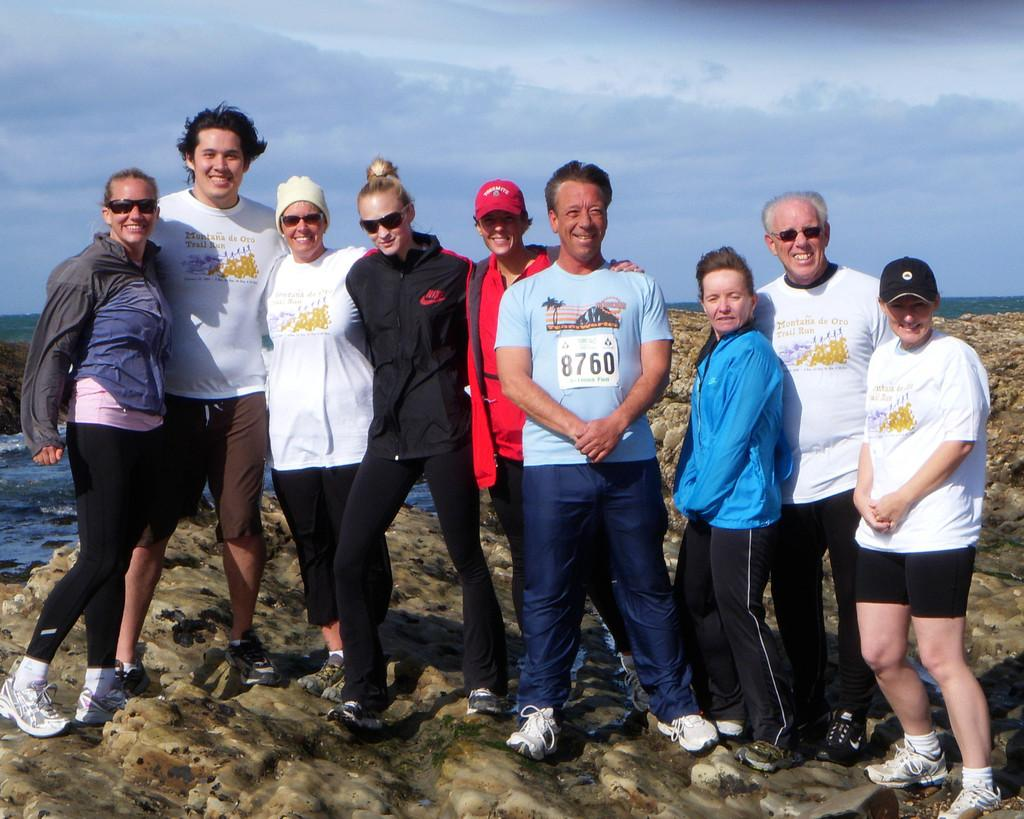What can be seen in the image? There are people standing in the image. What is visible in the background of the image? There is sky visible in the background of the image. What else is present in the image besides people? There is water and rocks visible in the image. What type of paper is being used for the test in the image? There is no paper or test present in the image; it features people standing near water and rocks with sky visible in the background. 